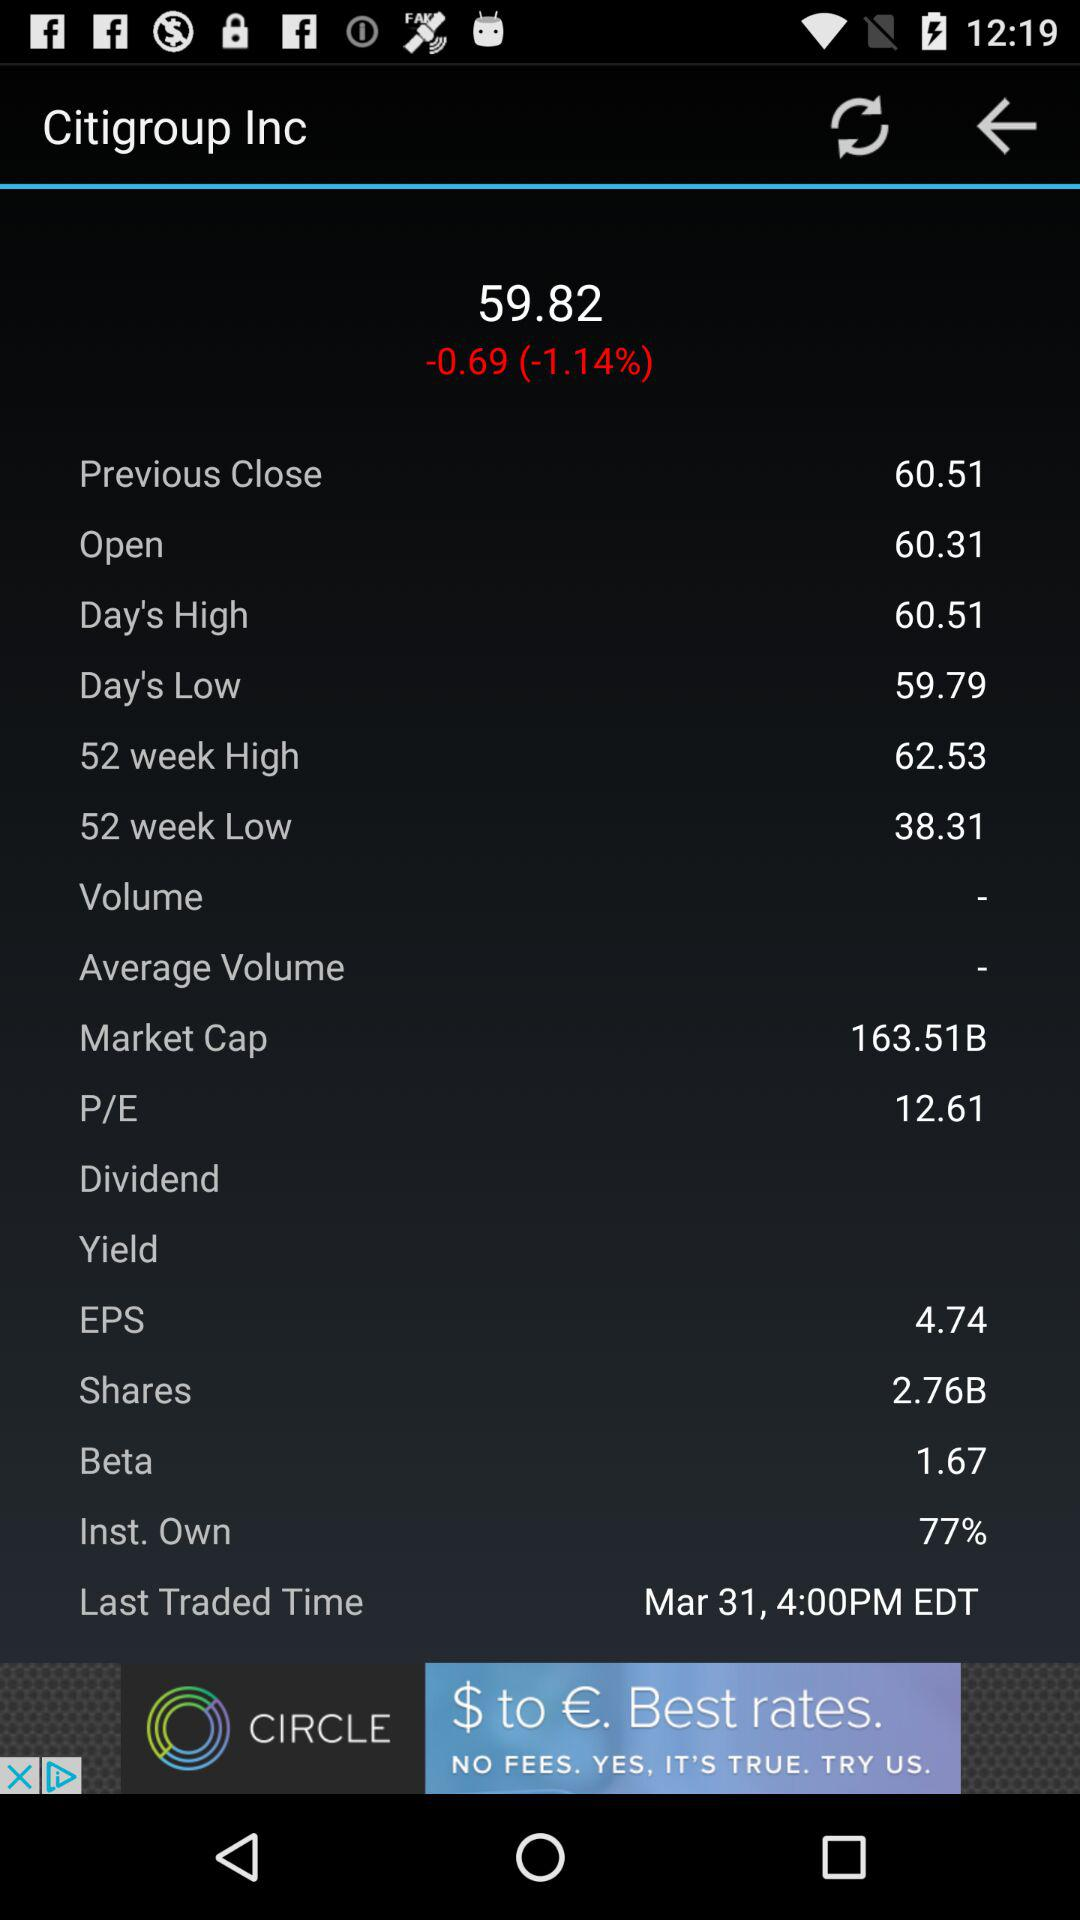What is the last traded date? The last traded date is March 31. 